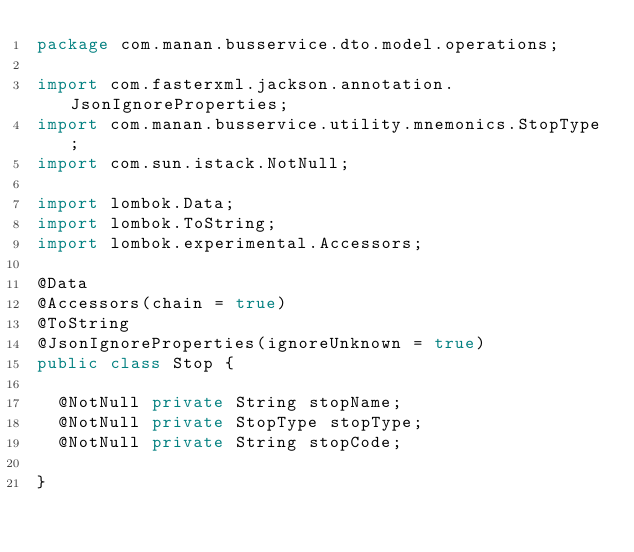<code> <loc_0><loc_0><loc_500><loc_500><_Java_>package com.manan.busservice.dto.model.operations;

import com.fasterxml.jackson.annotation.JsonIgnoreProperties;
import com.manan.busservice.utility.mnemonics.StopType;
import com.sun.istack.NotNull;

import lombok.Data;
import lombok.ToString;
import lombok.experimental.Accessors;

@Data
@Accessors(chain = true)
@ToString
@JsonIgnoreProperties(ignoreUnknown = true)
public class Stop {
	
	@NotNull private String stopName;
	@NotNull private StopType stopType;
	@NotNull private String stopCode;

}
</code> 